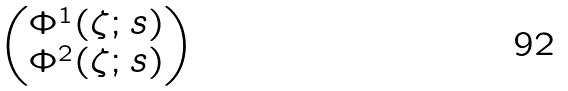Convert formula to latex. <formula><loc_0><loc_0><loc_500><loc_500>\begin{pmatrix} \Phi ^ { 1 } ( \zeta ; s ) \\ \Phi ^ { 2 } ( \zeta ; s ) \end{pmatrix}</formula> 